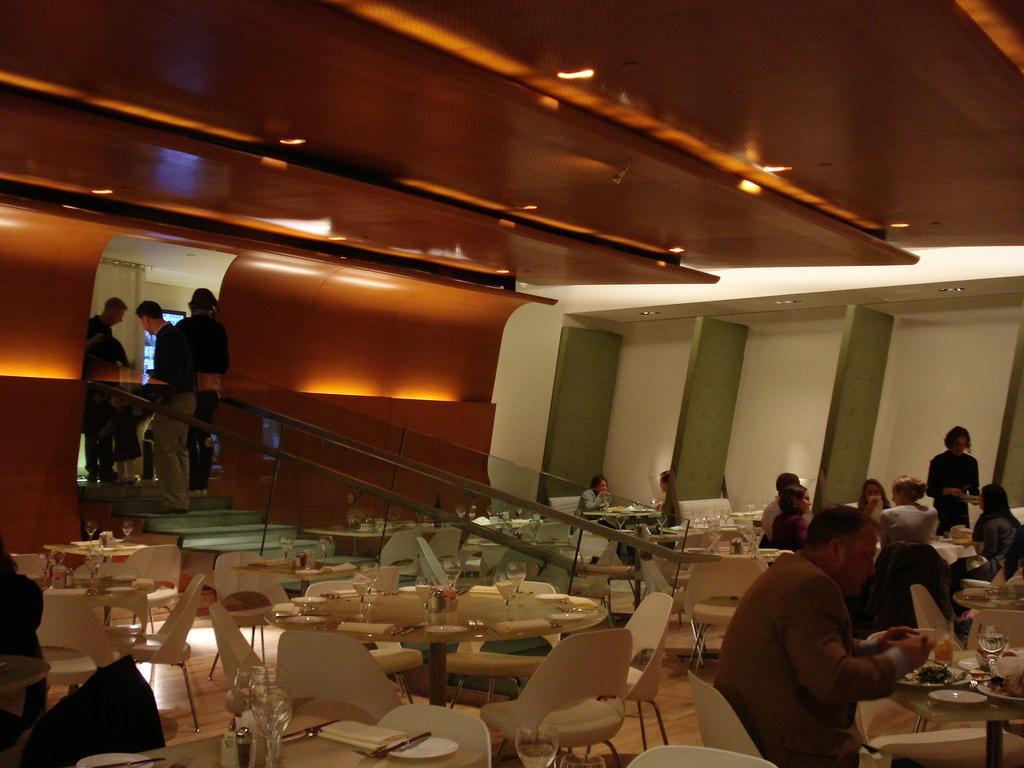Describe this image in one or two sentences. In this picture we can see group of people some are sitting on chair and some are standing on steps and in front of them there is table and on table we can see bowls, glasses, flowers and in background we can see wall, lights. 